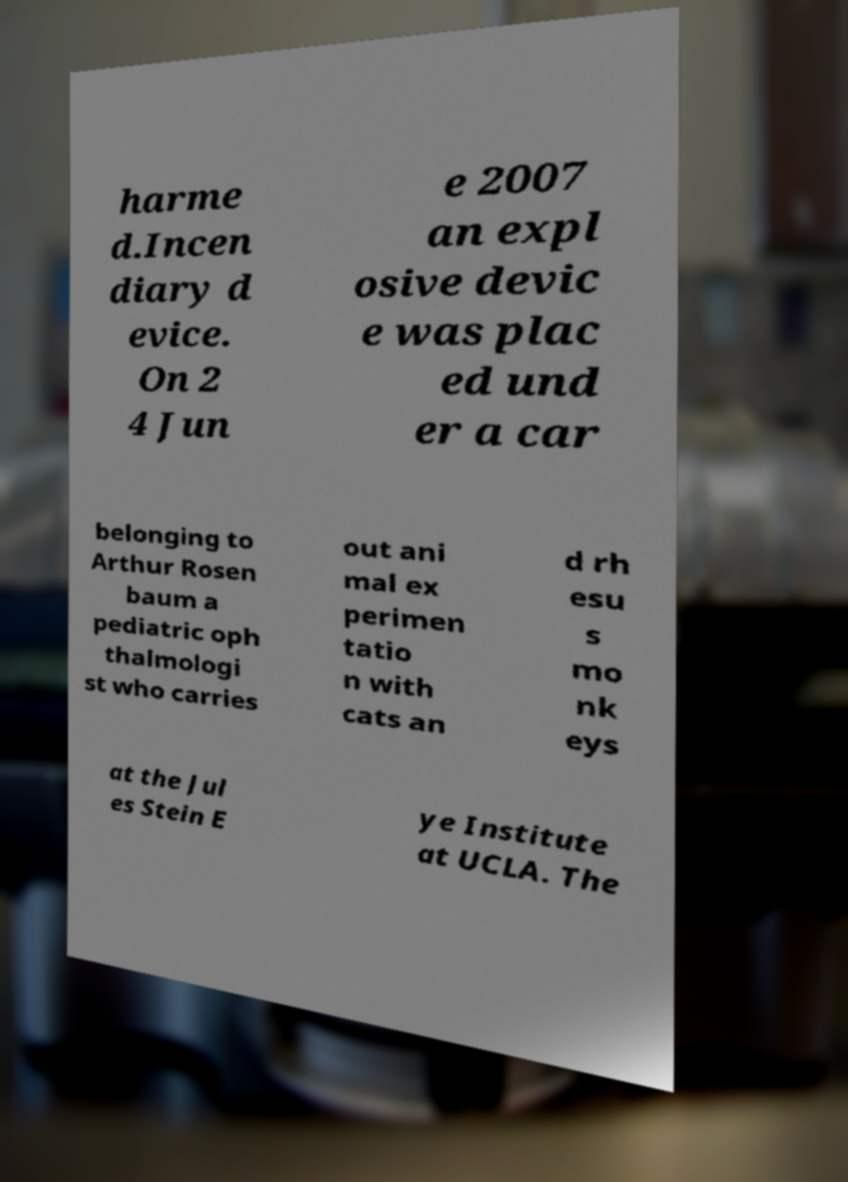Please read and relay the text visible in this image. What does it say? harme d.Incen diary d evice. On 2 4 Jun e 2007 an expl osive devic e was plac ed und er a car belonging to Arthur Rosen baum a pediatric oph thalmologi st who carries out ani mal ex perimen tatio n with cats an d rh esu s mo nk eys at the Jul es Stein E ye Institute at UCLA. The 